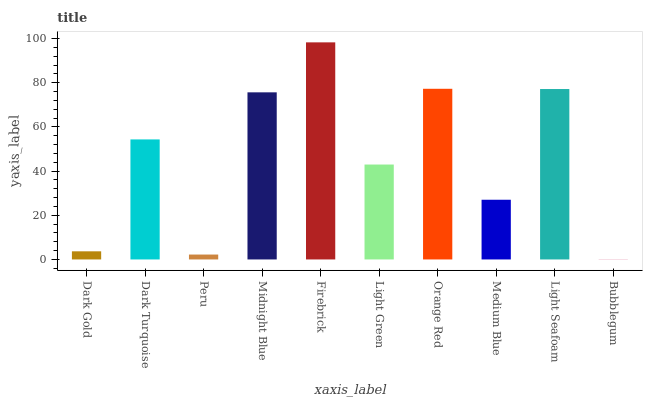Is Bubblegum the minimum?
Answer yes or no. Yes. Is Firebrick the maximum?
Answer yes or no. Yes. Is Dark Turquoise the minimum?
Answer yes or no. No. Is Dark Turquoise the maximum?
Answer yes or no. No. Is Dark Turquoise greater than Dark Gold?
Answer yes or no. Yes. Is Dark Gold less than Dark Turquoise?
Answer yes or no. Yes. Is Dark Gold greater than Dark Turquoise?
Answer yes or no. No. Is Dark Turquoise less than Dark Gold?
Answer yes or no. No. Is Dark Turquoise the high median?
Answer yes or no. Yes. Is Light Green the low median?
Answer yes or no. Yes. Is Dark Gold the high median?
Answer yes or no. No. Is Orange Red the low median?
Answer yes or no. No. 